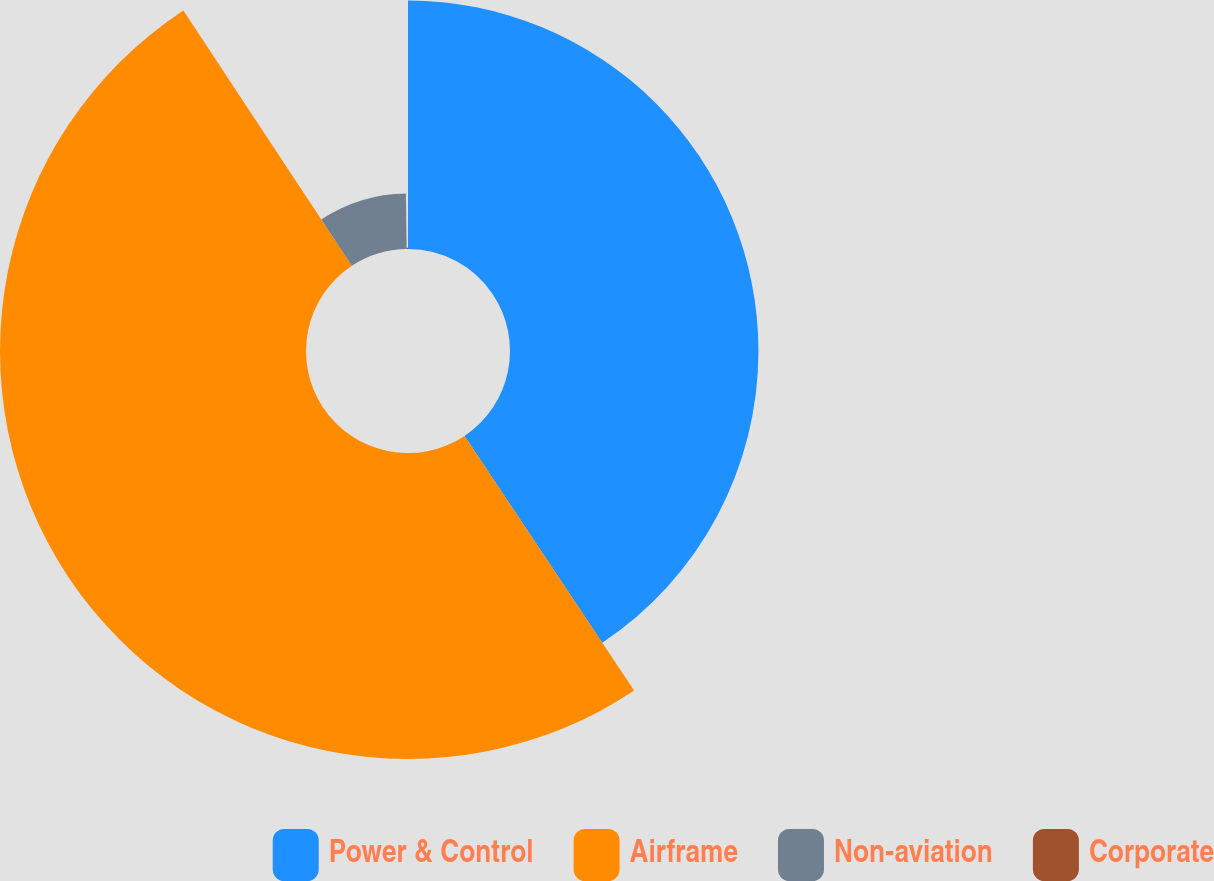Convert chart. <chart><loc_0><loc_0><loc_500><loc_500><pie_chart><fcel>Power & Control<fcel>Airframe<fcel>Non-aviation<fcel>Corporate<nl><fcel>40.65%<fcel>50.07%<fcel>9.07%<fcel>0.21%<nl></chart> 